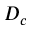<formula> <loc_0><loc_0><loc_500><loc_500>D _ { c }</formula> 